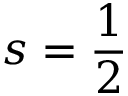Convert formula to latex. <formula><loc_0><loc_0><loc_500><loc_500>s = { \frac { 1 } { 2 } }</formula> 